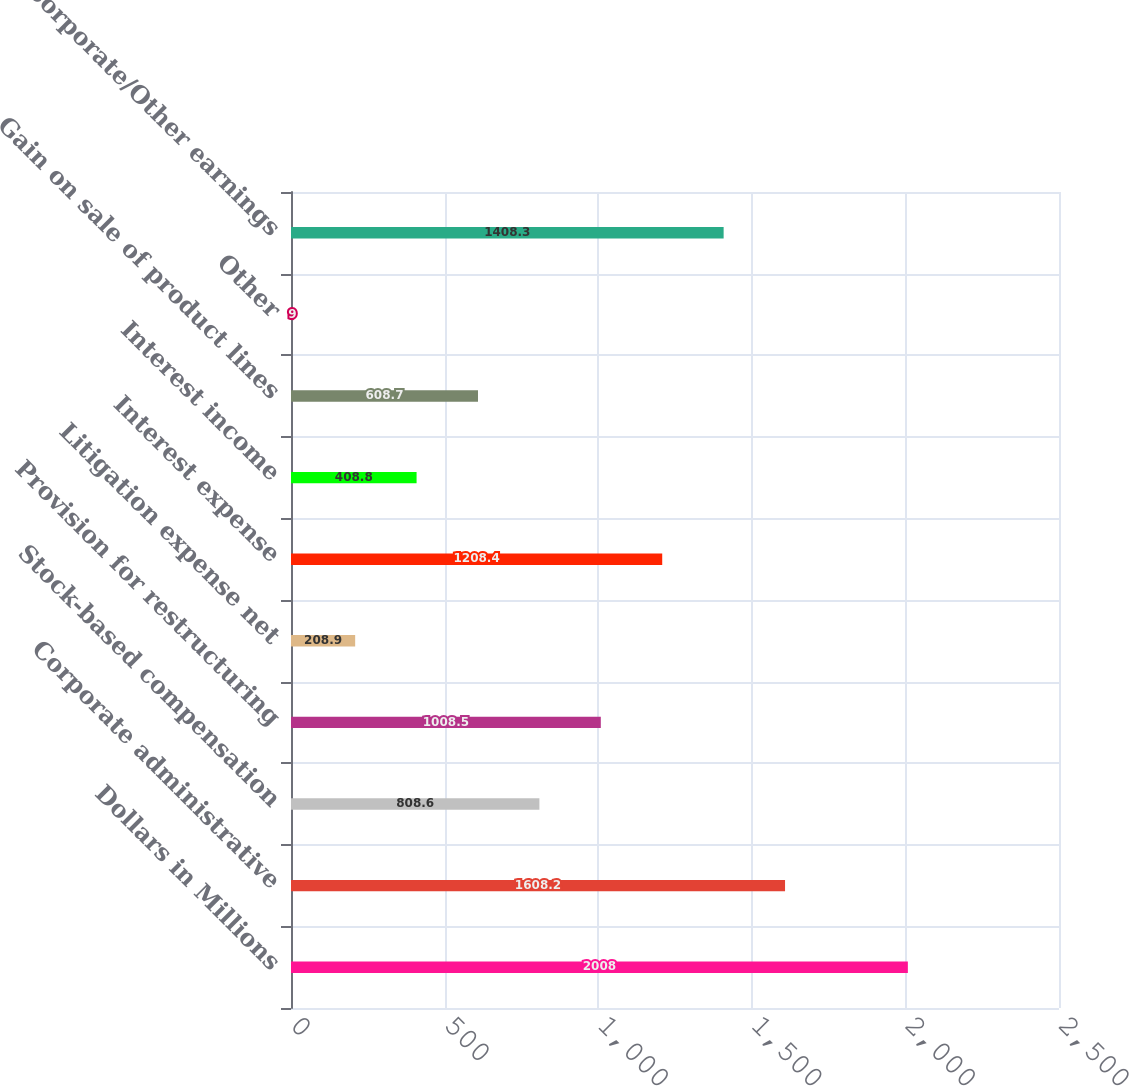Convert chart to OTSL. <chart><loc_0><loc_0><loc_500><loc_500><bar_chart><fcel>Dollars in Millions<fcel>Corporate administrative<fcel>Stock-based compensation<fcel>Provision for restructuring<fcel>Litigation expense net<fcel>Interest expense<fcel>Interest income<fcel>Gain on sale of product lines<fcel>Other<fcel>Total Corporate/Other earnings<nl><fcel>2008<fcel>1608.2<fcel>808.6<fcel>1008.5<fcel>208.9<fcel>1208.4<fcel>408.8<fcel>608.7<fcel>9<fcel>1408.3<nl></chart> 